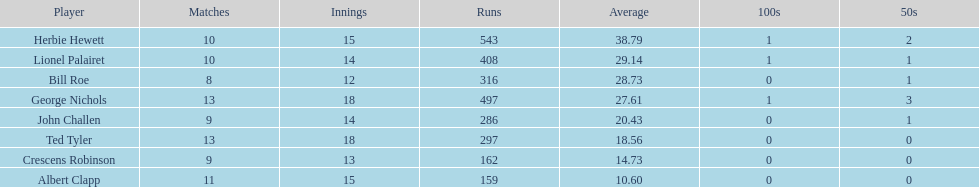What was the total number of runs ted tyler had? 297. 